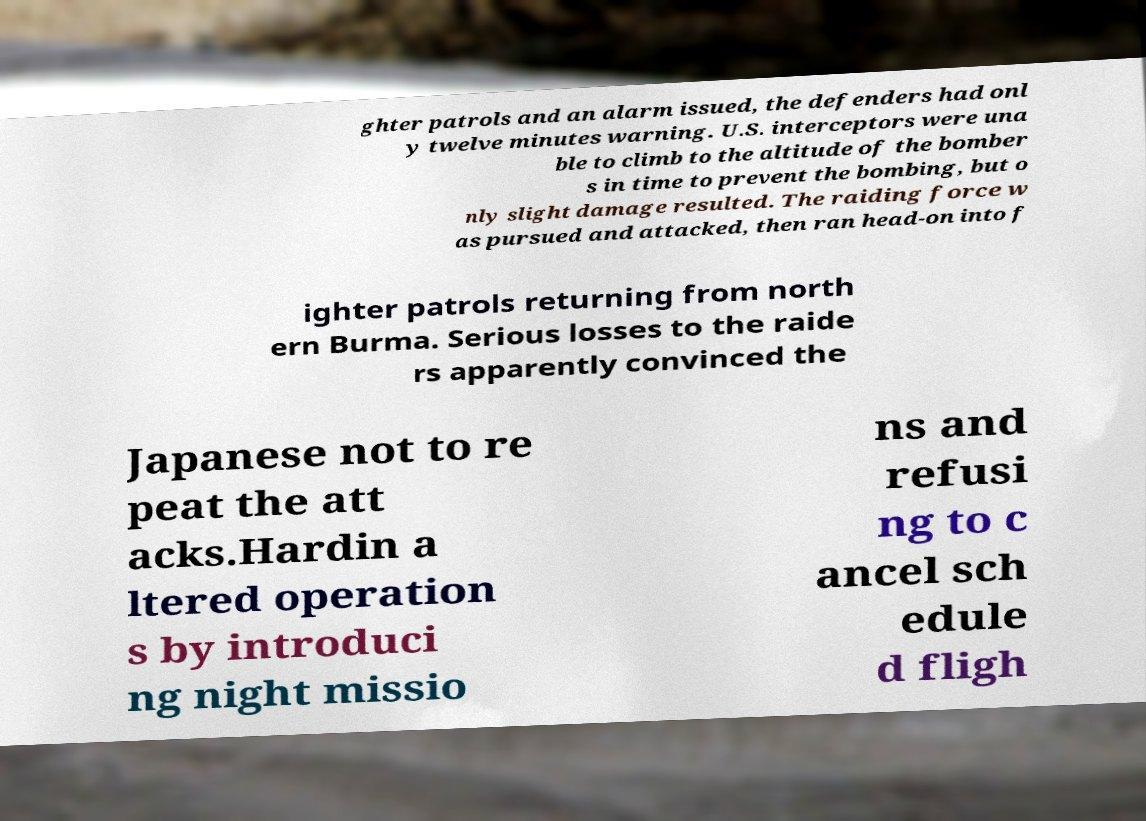Can you accurately transcribe the text from the provided image for me? ghter patrols and an alarm issued, the defenders had onl y twelve minutes warning. U.S. interceptors were una ble to climb to the altitude of the bomber s in time to prevent the bombing, but o nly slight damage resulted. The raiding force w as pursued and attacked, then ran head-on into f ighter patrols returning from north ern Burma. Serious losses to the raide rs apparently convinced the Japanese not to re peat the att acks.Hardin a ltered operation s by introduci ng night missio ns and refusi ng to c ancel sch edule d fligh 